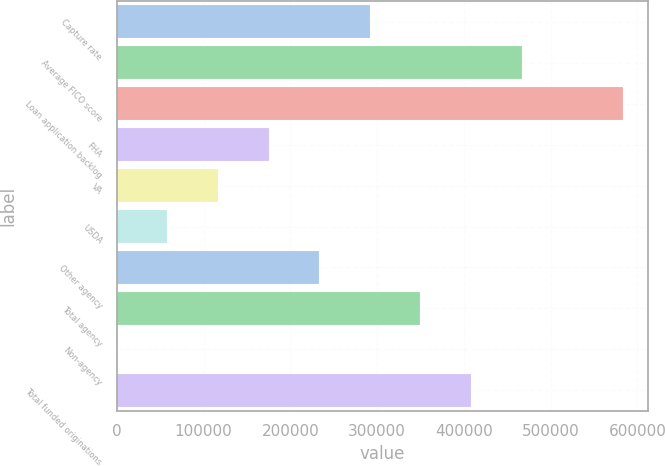Convert chart. <chart><loc_0><loc_0><loc_500><loc_500><bar_chart><fcel>Capture rate<fcel>Average FICO score<fcel>Loan application backlog<fcel>FHA<fcel>VA<fcel>USDA<fcel>Other agency<fcel>Total agency<fcel>Non-agency<fcel>Total funded originations<nl><fcel>291736<fcel>466778<fcel>583472<fcel>175042<fcel>116695<fcel>58348.1<fcel>233389<fcel>350084<fcel>1<fcel>408431<nl></chart> 